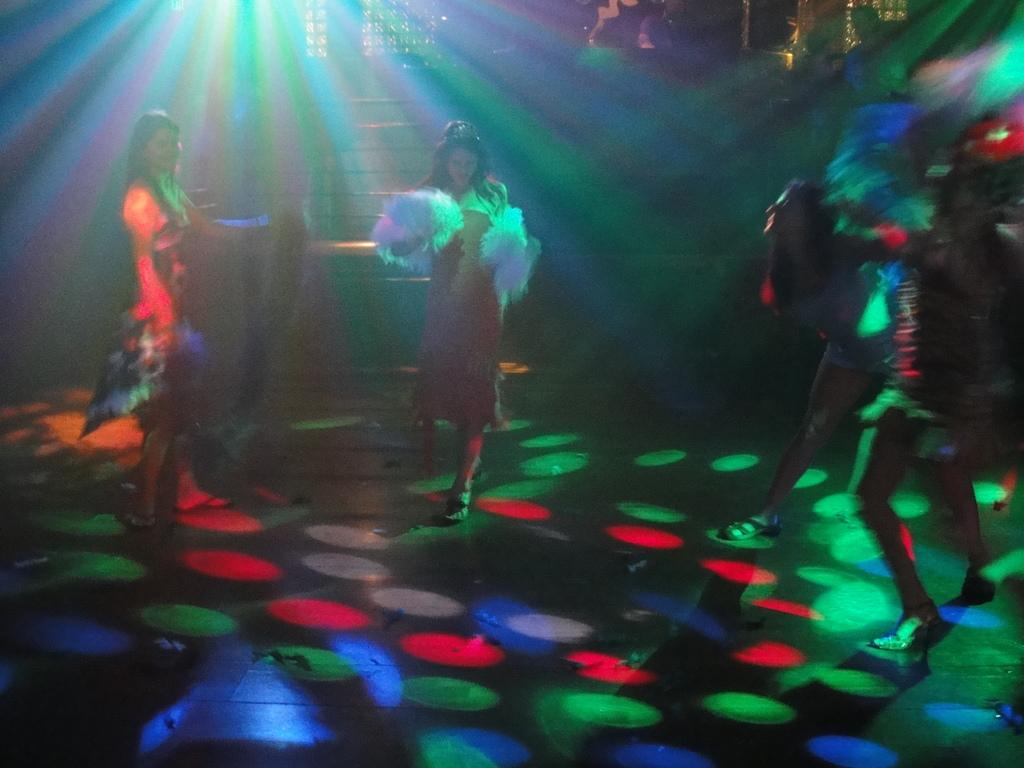What is the woman in the image doing? There is a woman walking on the floor in the image. Is there another woman in the image? Yes, there is a woman standing beside the walking woman. What can be seen in the background of the image? There are stairs visible in the background of the image. What activity is taking place on the right side of the image? There are people dancing on the right side of the image. What type of crack can be seen on the floor in the image? There is no crack visible on the floor in the image. What achievements have the dancing people accomplished in the image? The image does not provide information about the achievements of the dancing people. 